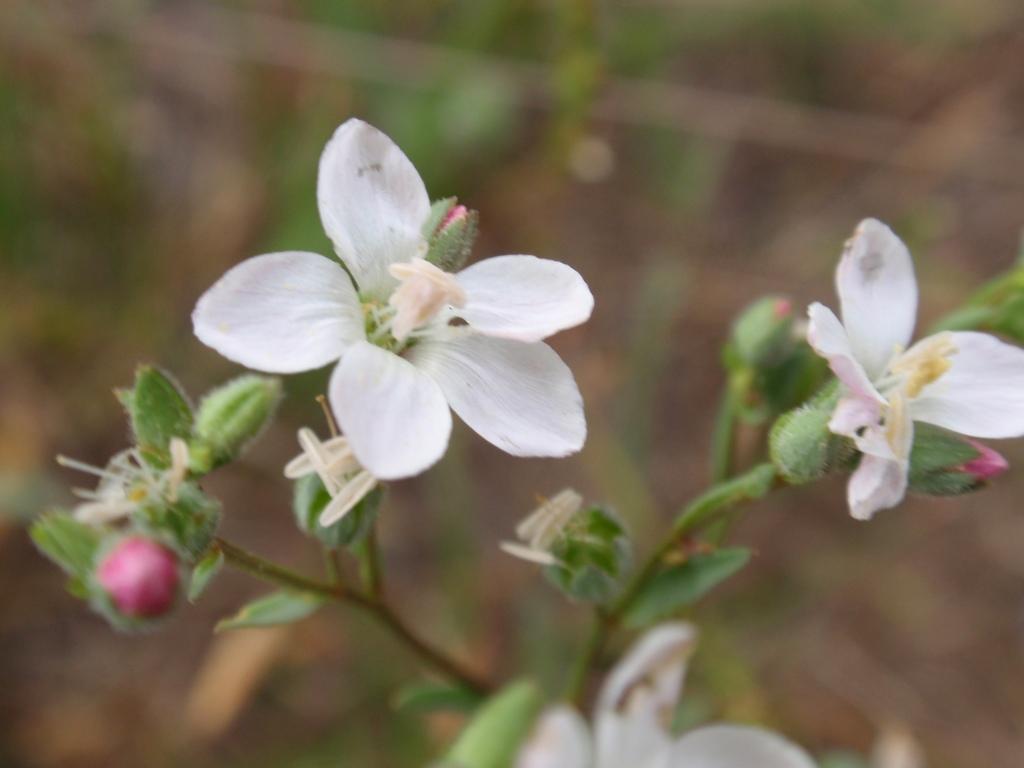Describe this image in one or two sentences. In the picture we can see a plant with a flower and buds, the flowers are white in color. 